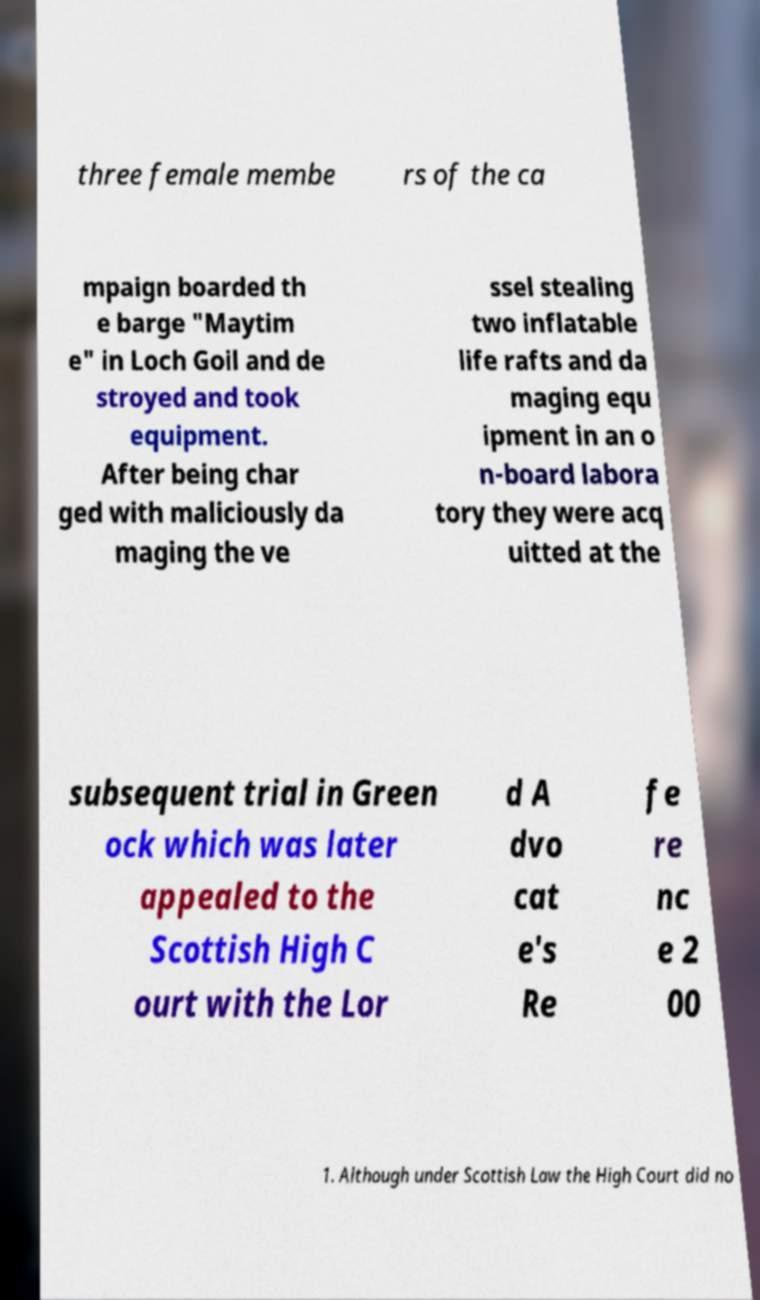Please identify and transcribe the text found in this image. three female membe rs of the ca mpaign boarded th e barge "Maytim e" in Loch Goil and de stroyed and took equipment. After being char ged with maliciously da maging the ve ssel stealing two inflatable life rafts and da maging equ ipment in an o n-board labora tory they were acq uitted at the subsequent trial in Green ock which was later appealed to the Scottish High C ourt with the Lor d A dvo cat e's Re fe re nc e 2 00 1. Although under Scottish Law the High Court did no 